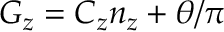Convert formula to latex. <formula><loc_0><loc_0><loc_500><loc_500>G _ { z } = C _ { z } n _ { z } + \theta / \pi</formula> 